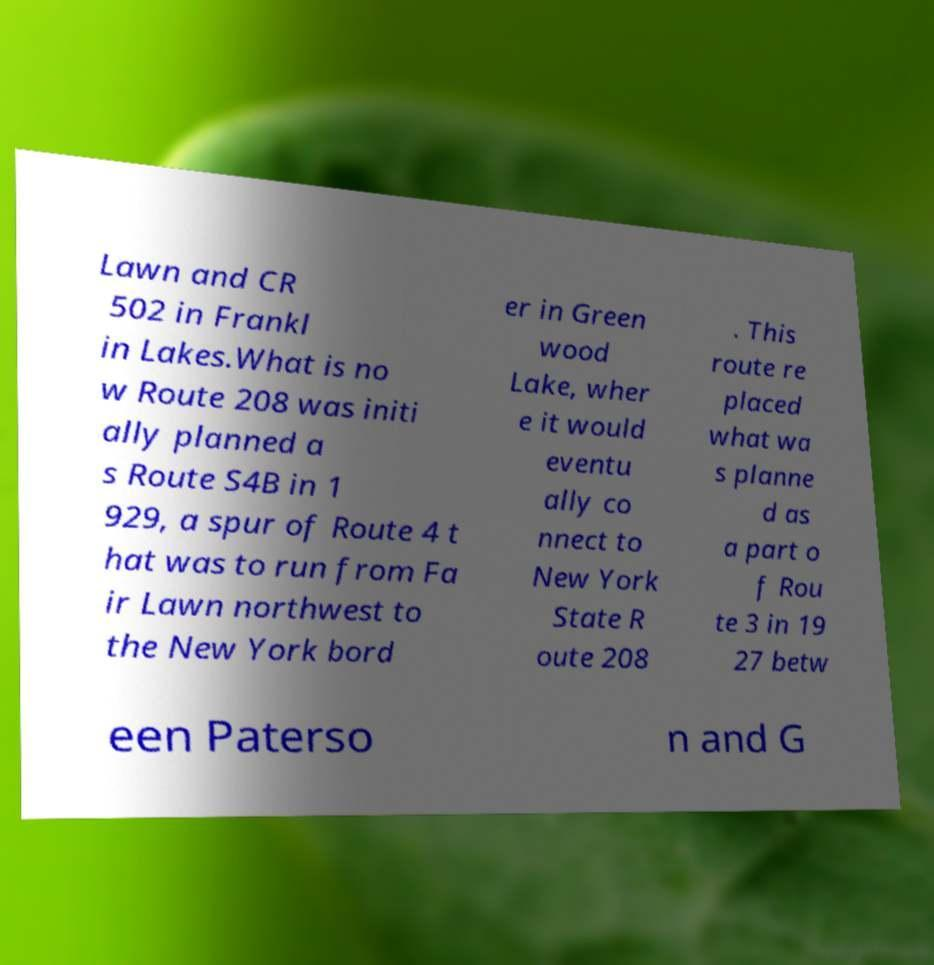For documentation purposes, I need the text within this image transcribed. Could you provide that? Lawn and CR 502 in Frankl in Lakes.What is no w Route 208 was initi ally planned a s Route S4B in 1 929, a spur of Route 4 t hat was to run from Fa ir Lawn northwest to the New York bord er in Green wood Lake, wher e it would eventu ally co nnect to New York State R oute 208 . This route re placed what wa s planne d as a part o f Rou te 3 in 19 27 betw een Paterso n and G 